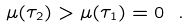<formula> <loc_0><loc_0><loc_500><loc_500>\mu ( \tau _ { 2 } ) > \mu ( \tau _ { 1 } ) = 0 \ .</formula> 